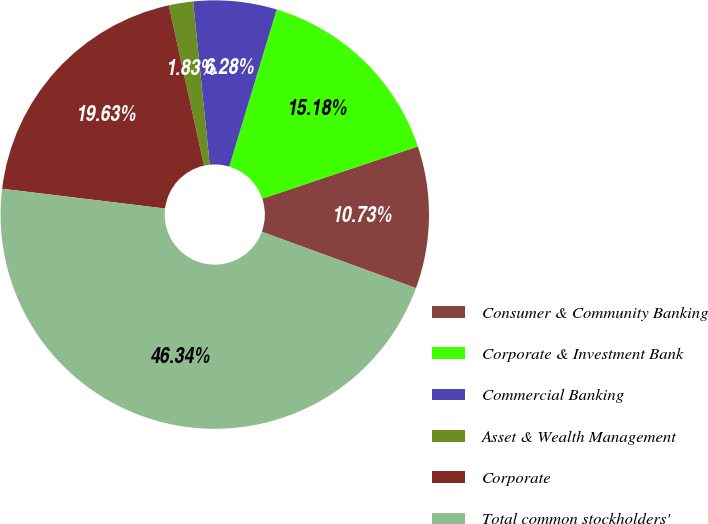Convert chart to OTSL. <chart><loc_0><loc_0><loc_500><loc_500><pie_chart><fcel>Consumer & Community Banking<fcel>Corporate & Investment Bank<fcel>Commercial Banking<fcel>Asset & Wealth Management<fcel>Corporate<fcel>Total common stockholders'<nl><fcel>10.73%<fcel>15.18%<fcel>6.28%<fcel>1.83%<fcel>19.63%<fcel>46.34%<nl></chart> 